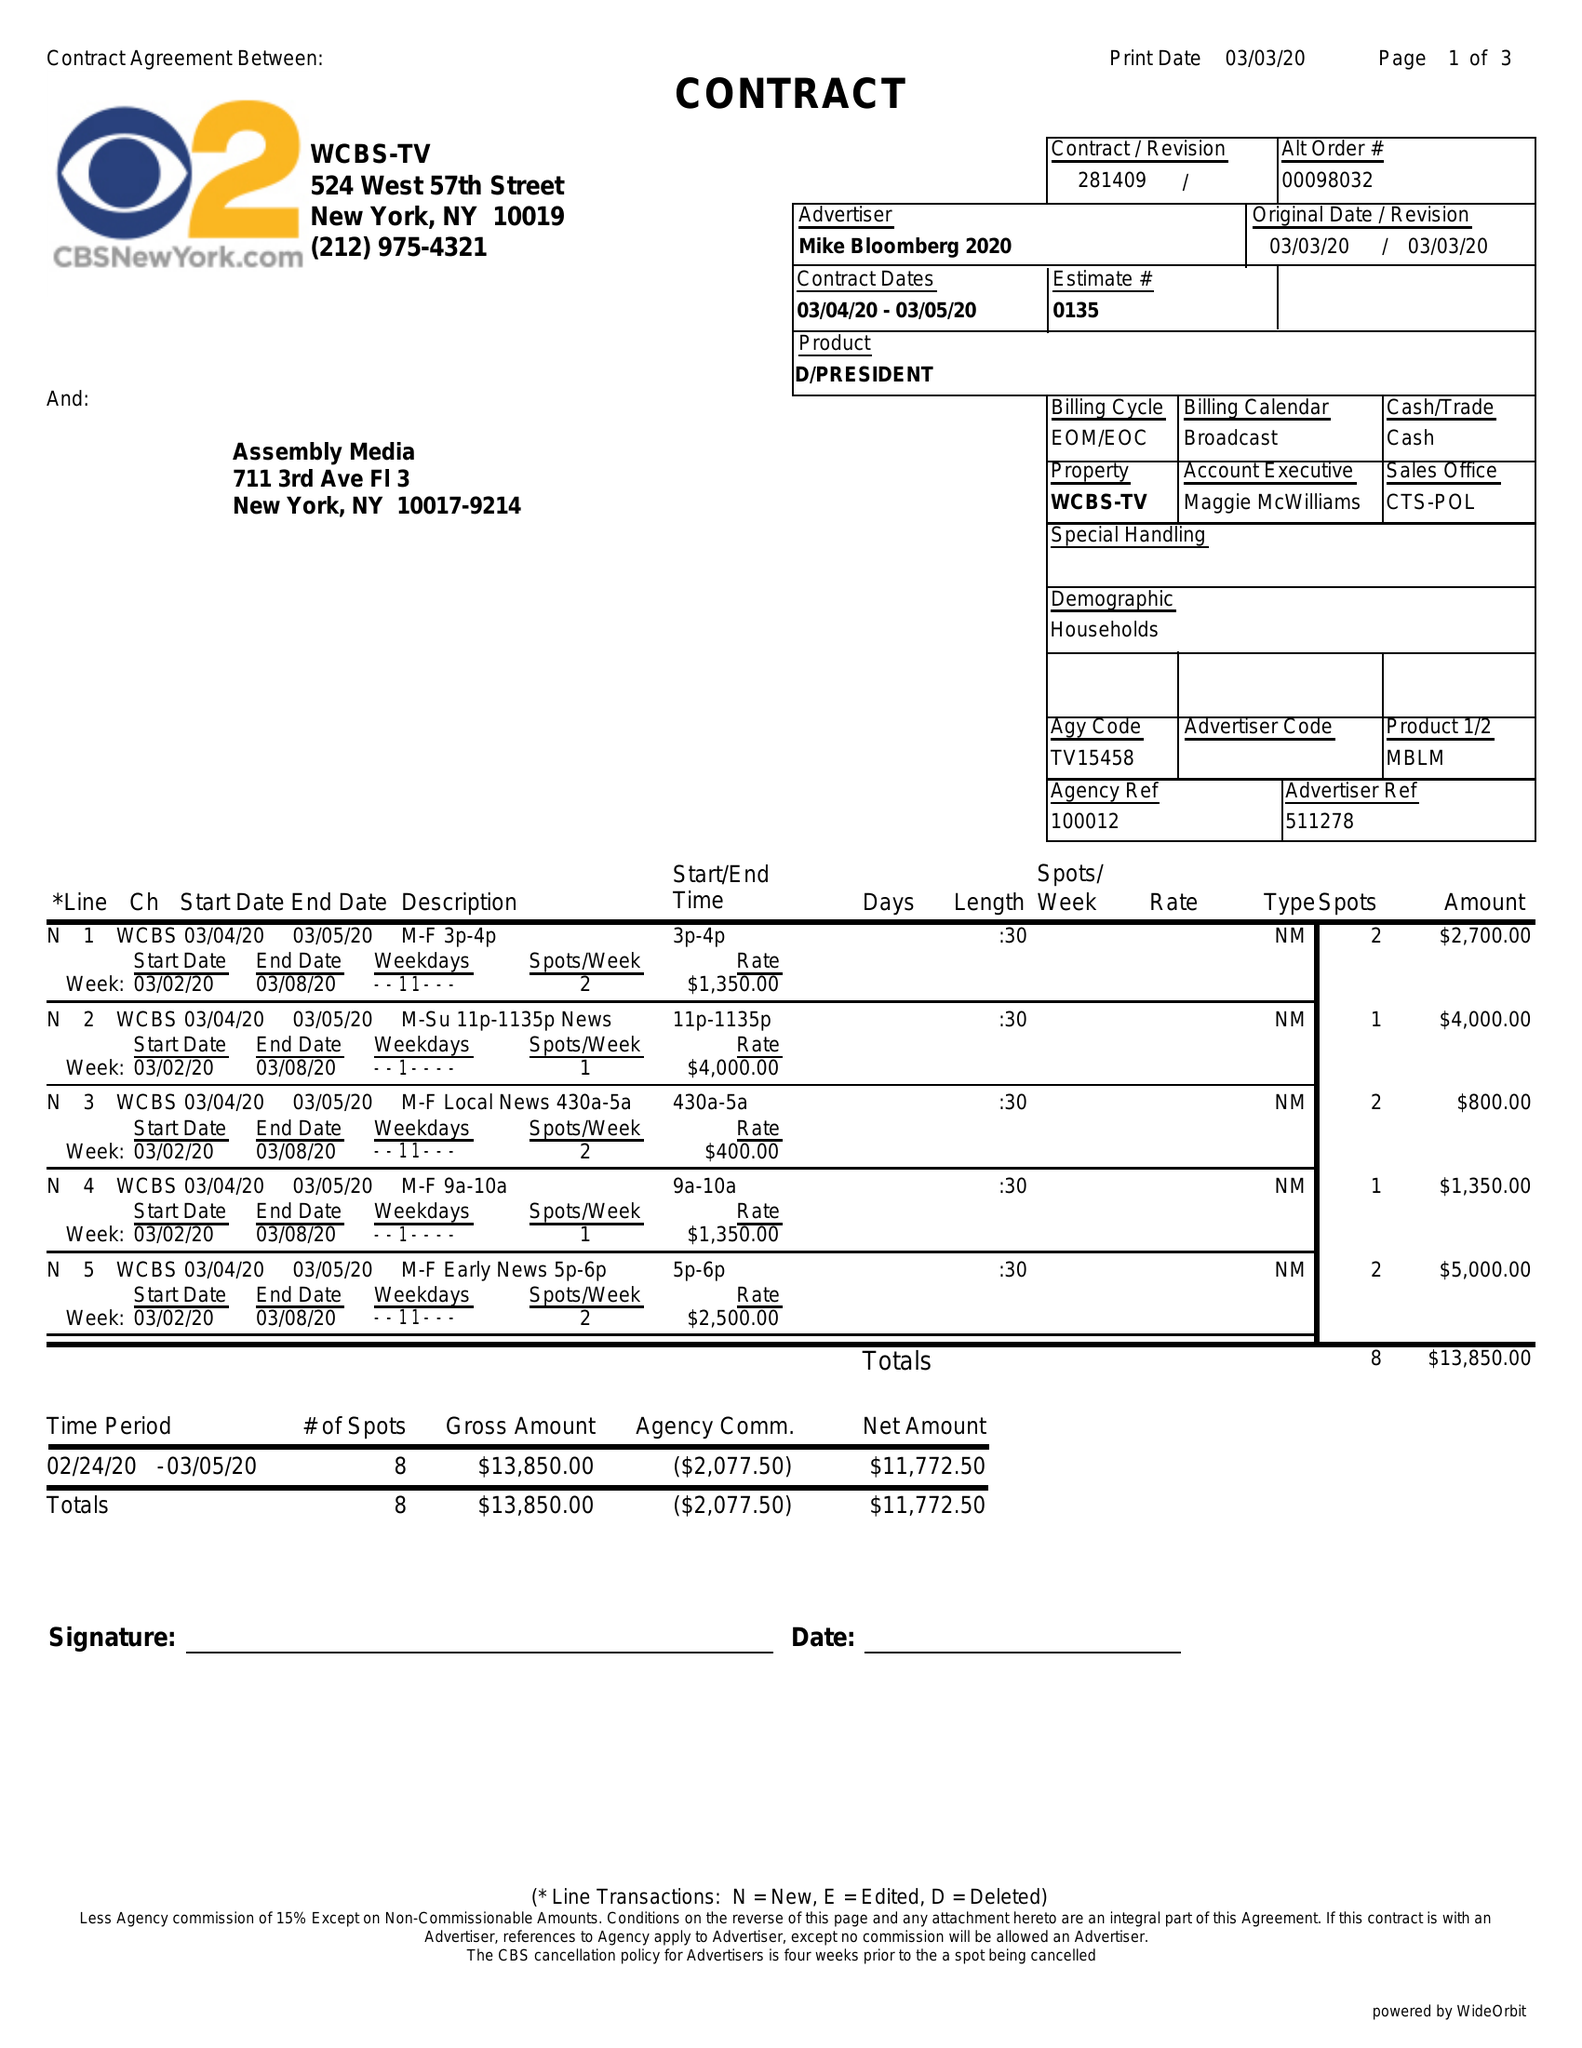What is the value for the contract_num?
Answer the question using a single word or phrase. 281409 